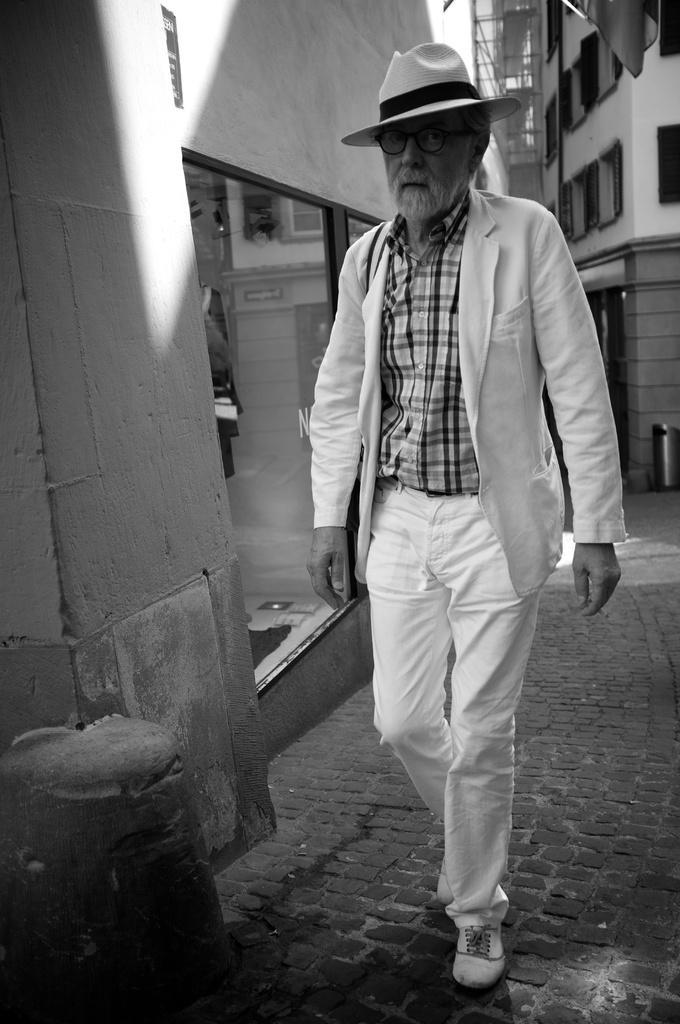How would you summarize this image in a sentence or two? This picture is in black and white. Towards the right, there is an old man wearing white blazer, white trousers, white hat and check shirt. In the background there are buildings. 